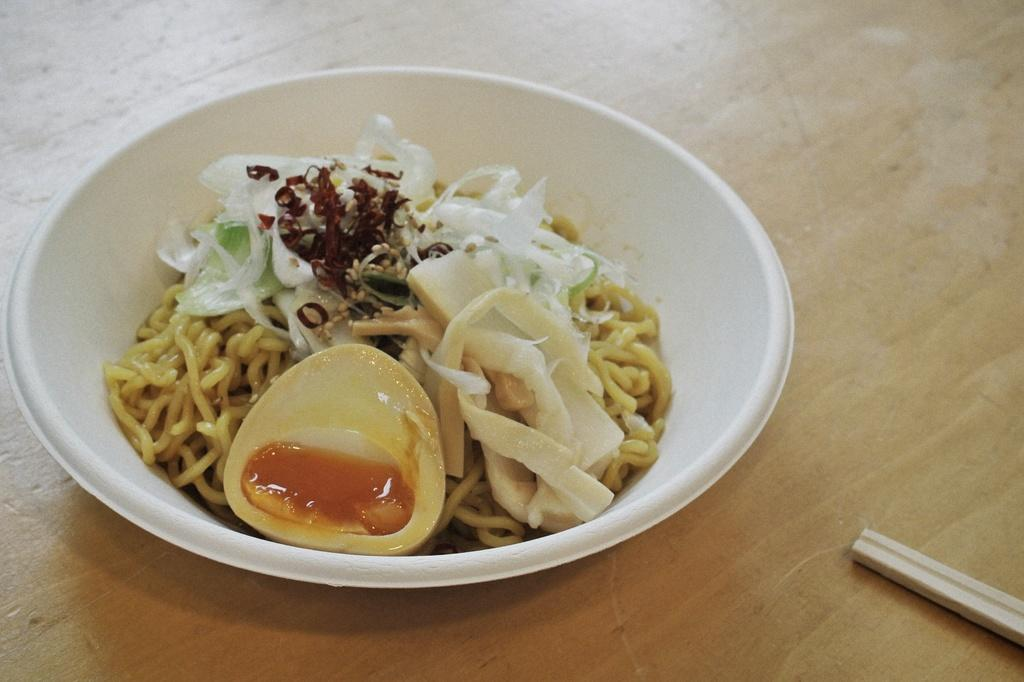What is inside the bowl that is visible in the image? There is food inside a bowl in the image. What color is the bowl? The bowl is white in color. Where is the bowl located in the image? The bowl is in the center of the image. What type of object can be seen on the right side of the image? There is a wooden object on the right side of the image. Is there a hose attached to the wooden object in the image? There is no hose present in the image, and the wooden object does not appear to be connected to any hose. 